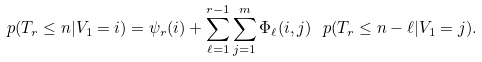Convert formula to latex. <formula><loc_0><loc_0><loc_500><loc_500>\ p ( T _ { r } \leq n | V _ { 1 } = i ) = \psi _ { r } ( i ) + \sum _ { \ell = 1 } ^ { r - 1 } \sum _ { j = 1 } ^ { m } \Phi _ { \ell } ( i , j ) \ p ( T _ { r } \leq n - \ell | V _ { 1 } = j ) .</formula> 